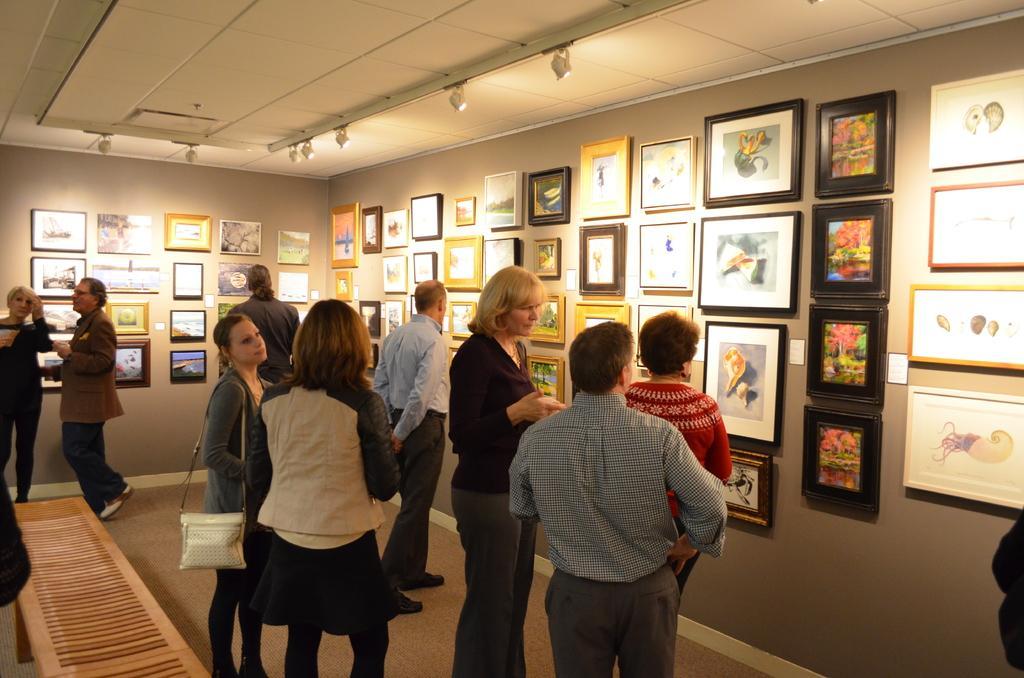Describe this image in one or two sentences. There are people and she is carrying a bag. We can see frames on the wall and bench on the surface. At the top we can see lights. 